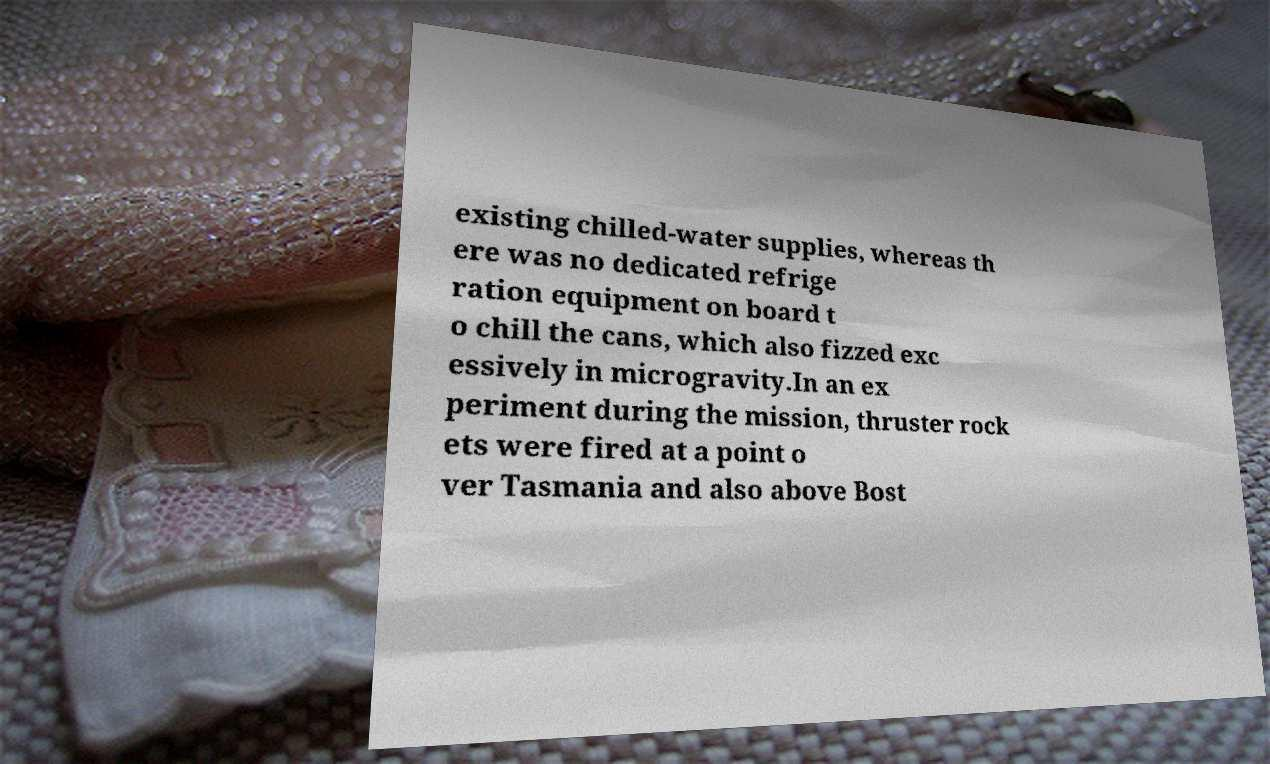Could you extract and type out the text from this image? existing chilled-water supplies, whereas th ere was no dedicated refrige ration equipment on board t o chill the cans, which also fizzed exc essively in microgravity.In an ex periment during the mission, thruster rock ets were fired at a point o ver Tasmania and also above Bost 